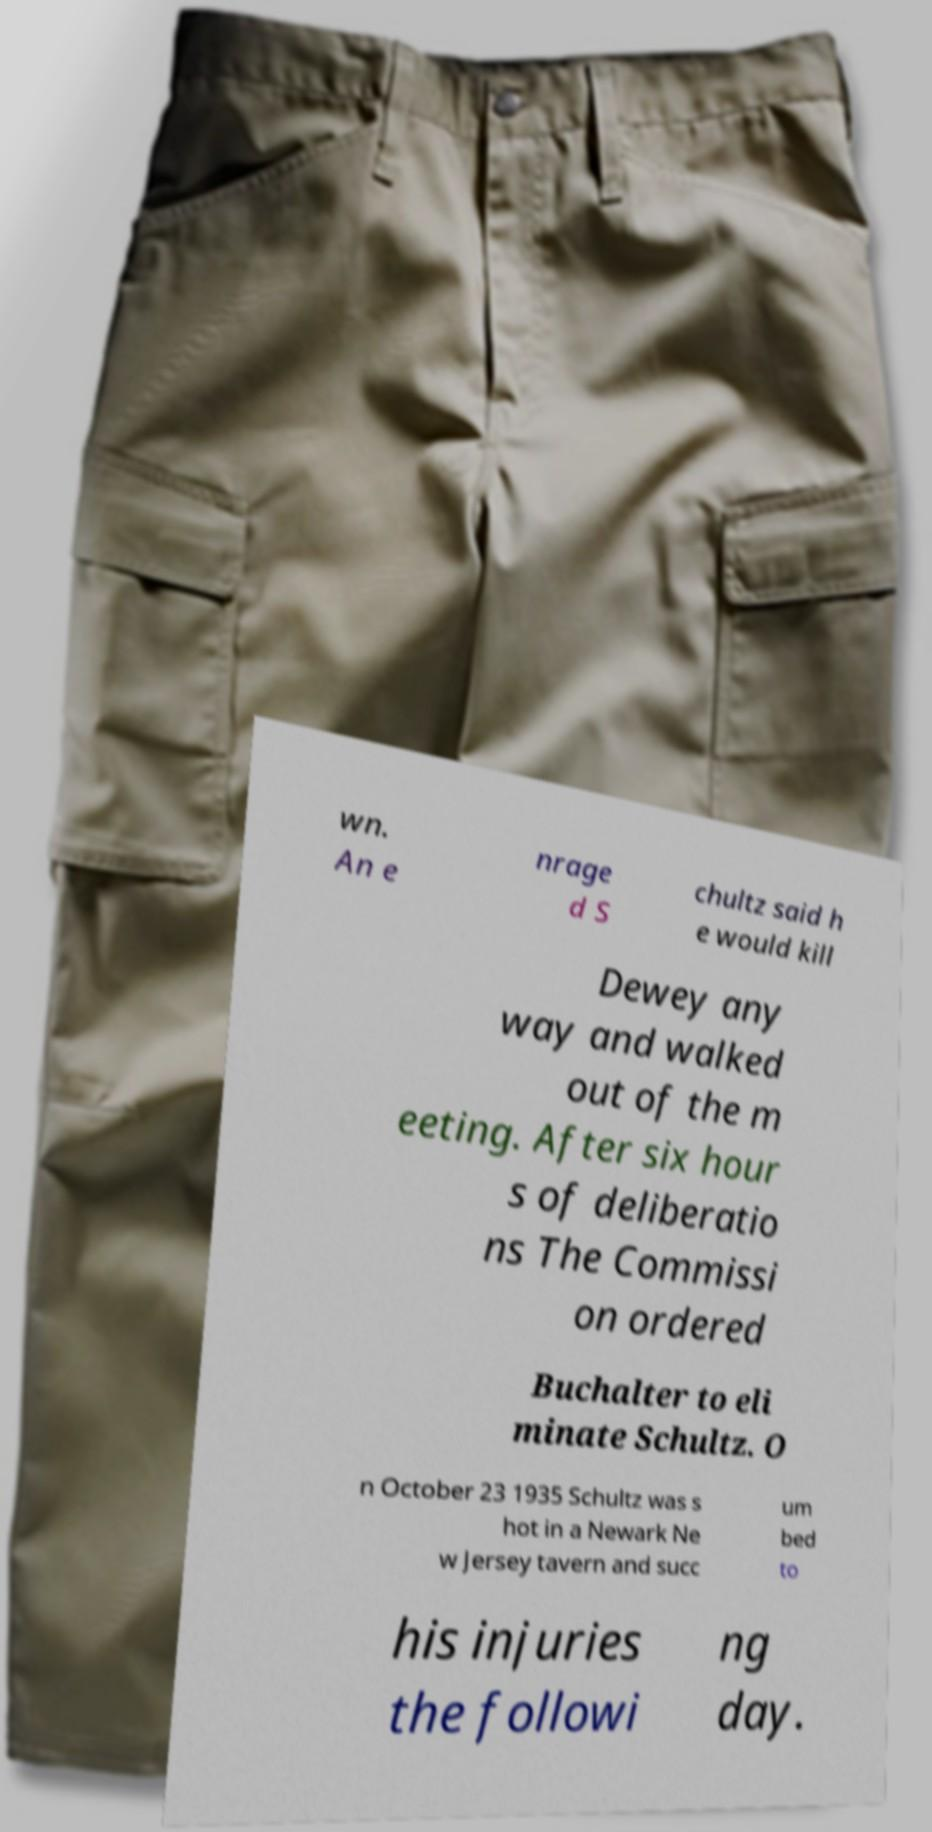Please identify and transcribe the text found in this image. wn. An e nrage d S chultz said h e would kill Dewey any way and walked out of the m eeting. After six hour s of deliberatio ns The Commissi on ordered Buchalter to eli minate Schultz. O n October 23 1935 Schultz was s hot in a Newark Ne w Jersey tavern and succ um bed to his injuries the followi ng day. 